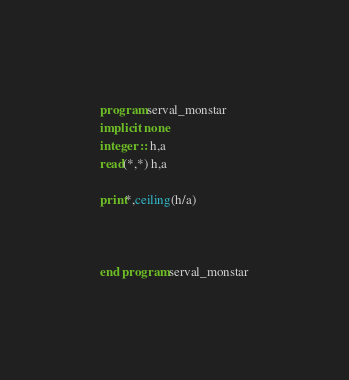Convert code to text. <code><loc_0><loc_0><loc_500><loc_500><_FORTRAN_>program serval_monstar
implicit none
integer :: h,a
read(*,*) h,a

print*,ceiling(h/a)



end program serval_monstar</code> 